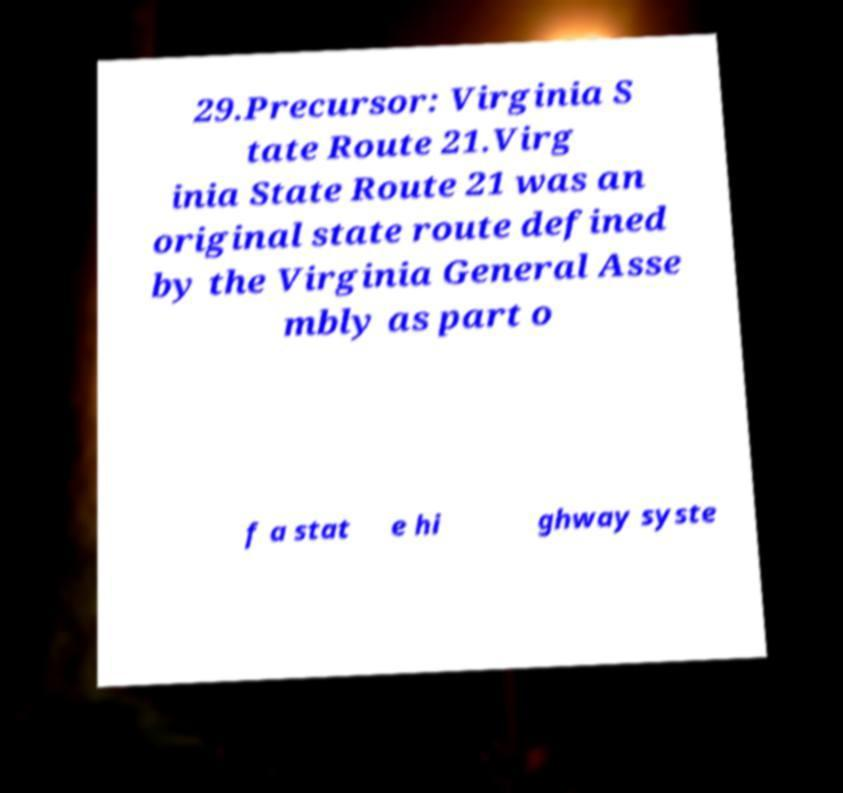Could you assist in decoding the text presented in this image and type it out clearly? 29.Precursor: Virginia S tate Route 21.Virg inia State Route 21 was an original state route defined by the Virginia General Asse mbly as part o f a stat e hi ghway syste 